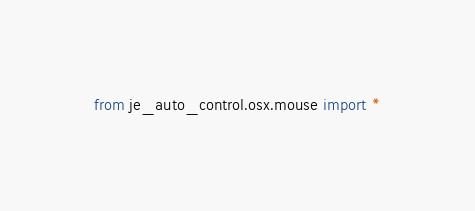<code> <loc_0><loc_0><loc_500><loc_500><_Python_>from je_auto_control.osx.mouse import *</code> 